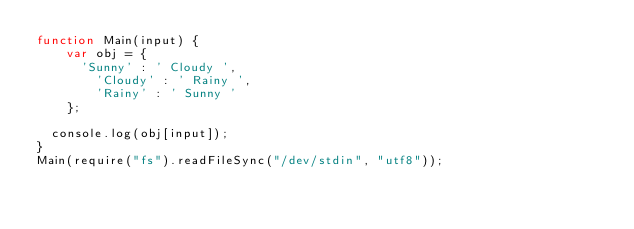Convert code to text. <code><loc_0><loc_0><loc_500><loc_500><_JavaScript_>function Main(input) {
    var obj = {
    	'Sunny' : ' Cloudy ',
        'Cloudy' : ' Rainy ',
        'Rainy' : ' Sunny '
    };
  
  console.log(obj[input]);
}
Main(require("fs").readFileSync("/dev/stdin", "utf8"));
</code> 